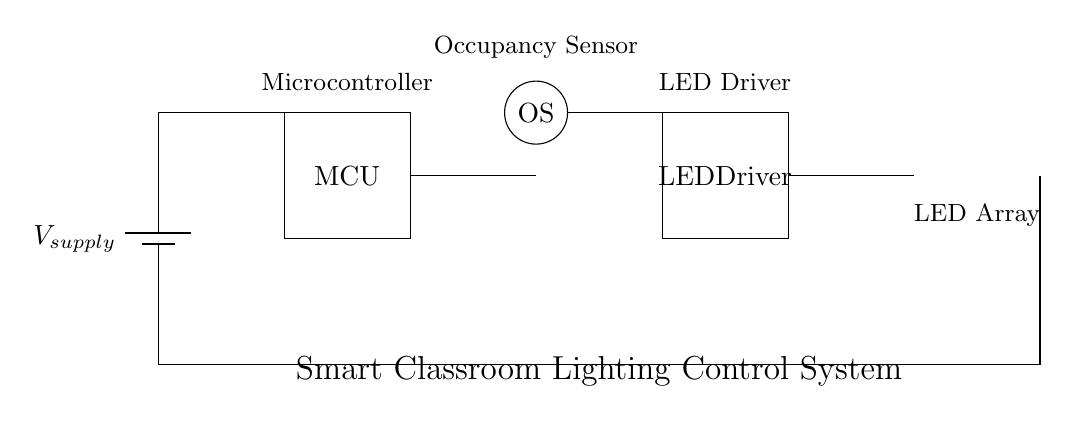What is the main power source for this circuit? The circuit diagram shows a battery labeled as V_supply, indicating it is the main power source providing electricity to the system.
Answer: Battery What does MCU stand for in this context? The acronym MCU refers to the Microcontroller Unit, which is a key component that controls the operation of the lighting system and processes input from the occupancy sensor.
Answer: Microcontroller Unit How many LED lights are connected in the LED array? The diagram illustrates three LED components connected in series as part of the LED array indicated at the right part of the circuit.
Answer: Three What is the function of the occupancy sensor? The occupancy sensor detects the presence of people in the classroom, and its output is used to control the LED array based on whether the space is occupied or not.
Answer: Detect presence What signal does the microcontroller receive? The microcontroller receives input signals from the occupancy sensor to determine whether to turn the LED lights on or off based on occupancy.
Answer: Input signals Explain how the different components interconnect in this circuit. The components interconnect such that the battery provides power to the microcontroller and the LED driver. The occupancy sensor sends its signal to the microcontroller to control the LED driver, which subsequently powers the LED array when needed.
Answer: Battery to MCU, MCU to Driver, Sensor to MCU 